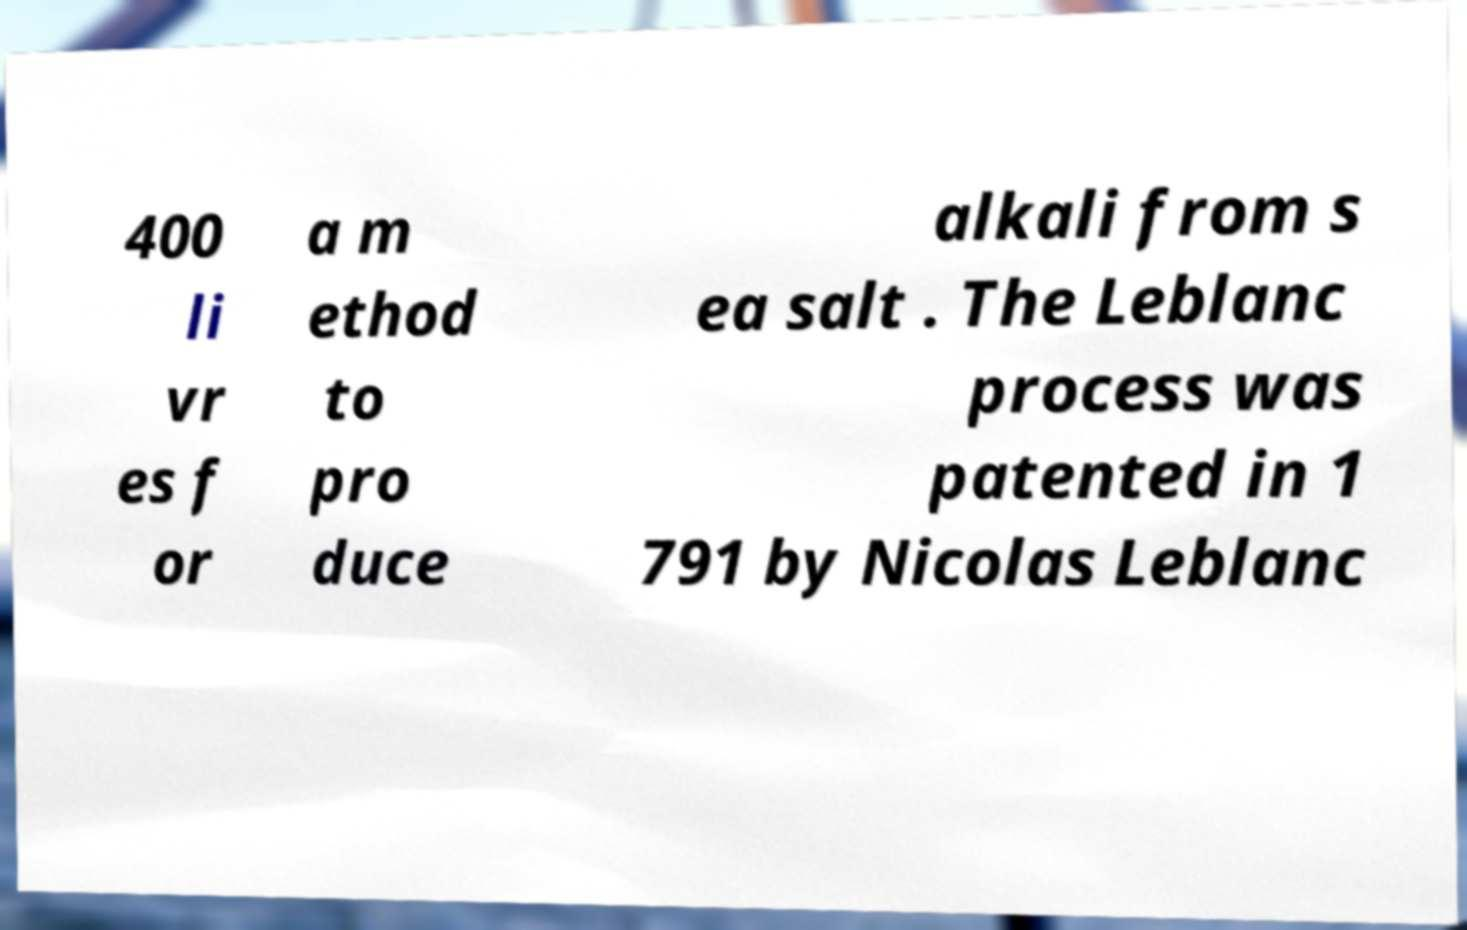Can you accurately transcribe the text from the provided image for me? 400 li vr es f or a m ethod to pro duce alkali from s ea salt . The Leblanc process was patented in 1 791 by Nicolas Leblanc 